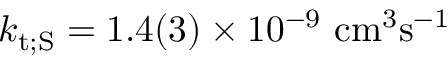Convert formula to latex. <formula><loc_0><loc_0><loc_500><loc_500>k _ { t ; S } = 1 . 4 ( 3 ) \times 1 0 ^ { - 9 } c m ^ { 3 } s ^ { - 1 }</formula> 